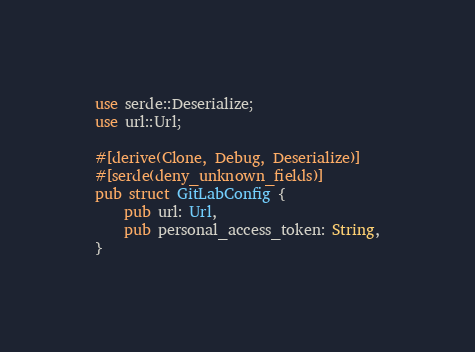Convert code to text. <code><loc_0><loc_0><loc_500><loc_500><_Rust_>use serde::Deserialize;
use url::Url;

#[derive(Clone, Debug, Deserialize)]
#[serde(deny_unknown_fields)]
pub struct GitLabConfig {
    pub url: Url,
    pub personal_access_token: String,
}
</code> 